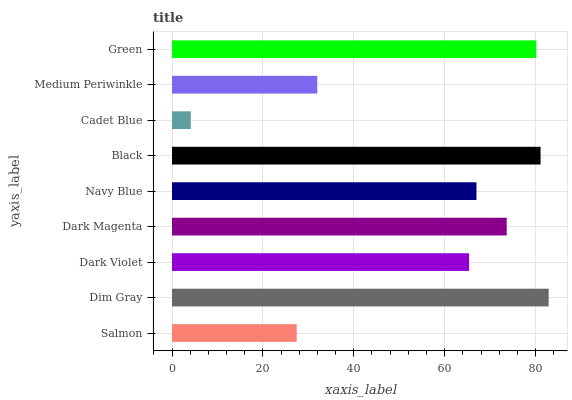Is Cadet Blue the minimum?
Answer yes or no. Yes. Is Dim Gray the maximum?
Answer yes or no. Yes. Is Dark Violet the minimum?
Answer yes or no. No. Is Dark Violet the maximum?
Answer yes or no. No. Is Dim Gray greater than Dark Violet?
Answer yes or no. Yes. Is Dark Violet less than Dim Gray?
Answer yes or no. Yes. Is Dark Violet greater than Dim Gray?
Answer yes or no. No. Is Dim Gray less than Dark Violet?
Answer yes or no. No. Is Navy Blue the high median?
Answer yes or no. Yes. Is Navy Blue the low median?
Answer yes or no. Yes. Is Medium Periwinkle the high median?
Answer yes or no. No. Is Salmon the low median?
Answer yes or no. No. 